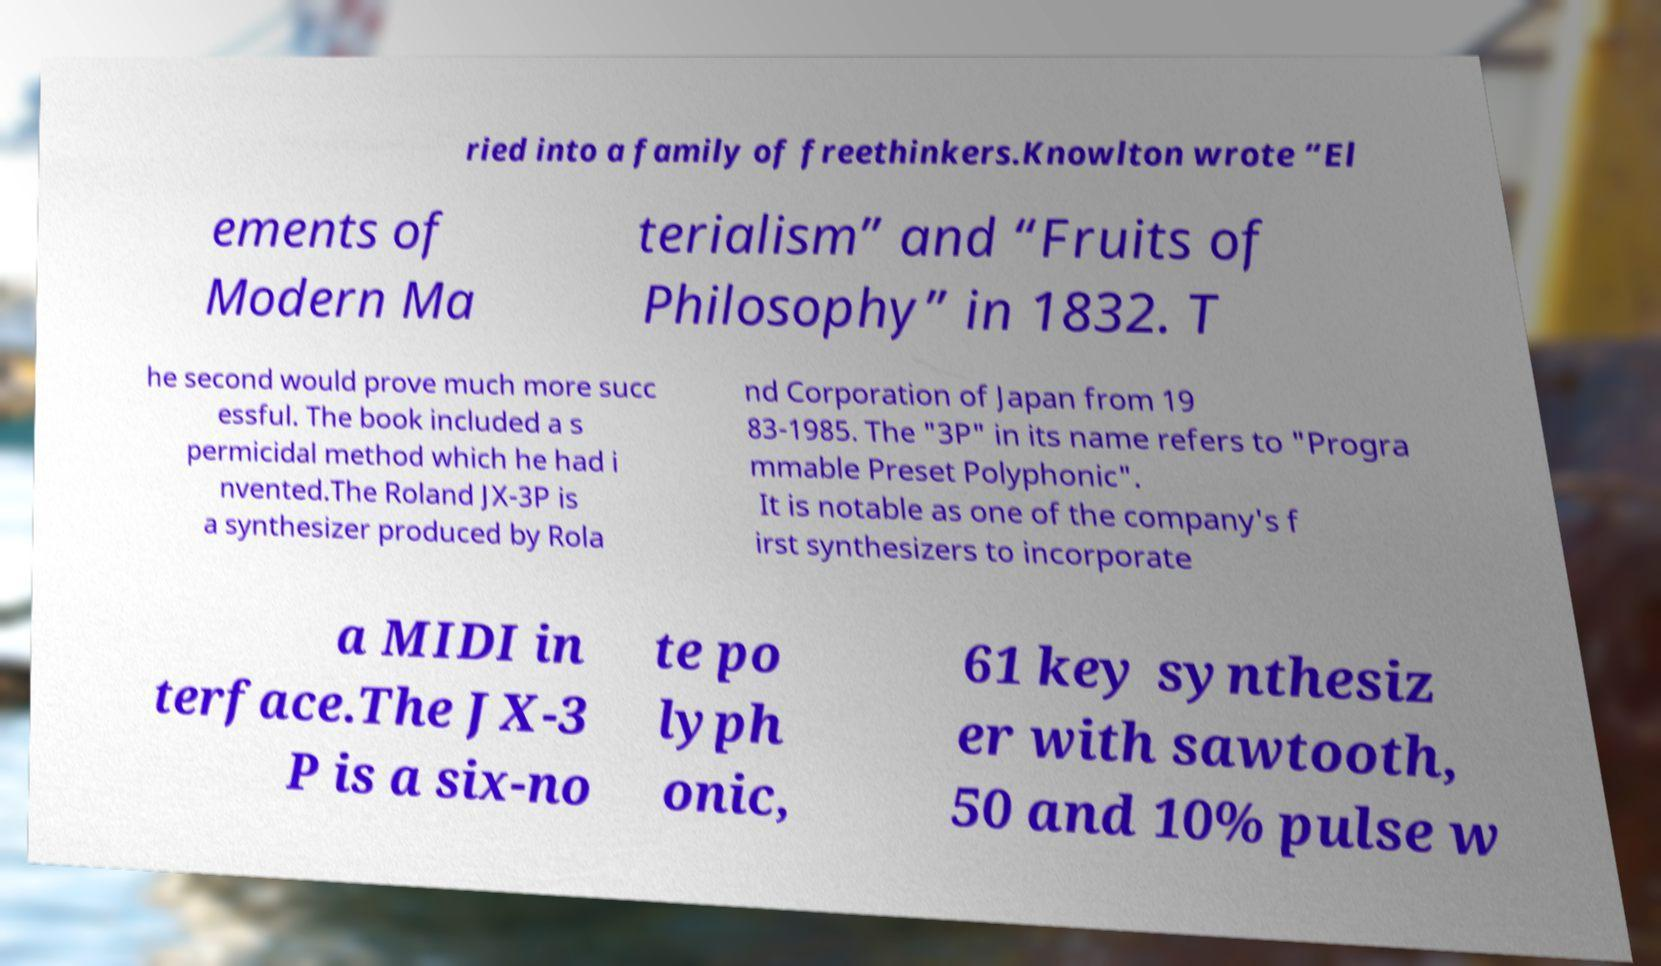Can you accurately transcribe the text from the provided image for me? ried into a family of freethinkers.Knowlton wrote “El ements of Modern Ma terialism” and “Fruits of Philosophy” in 1832. T he second would prove much more succ essful. The book included a s permicidal method which he had i nvented.The Roland JX-3P is a synthesizer produced by Rola nd Corporation of Japan from 19 83-1985. The "3P" in its name refers to "Progra mmable Preset Polyphonic". It is notable as one of the company's f irst synthesizers to incorporate a MIDI in terface.The JX-3 P is a six-no te po lyph onic, 61 key synthesiz er with sawtooth, 50 and 10% pulse w 